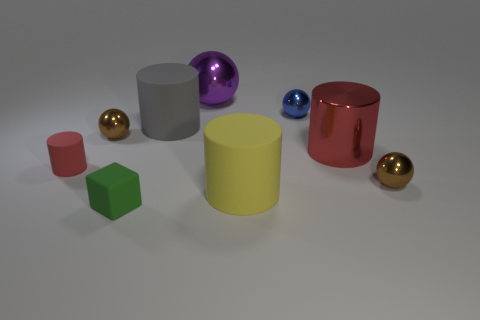The object that is the same color as the small rubber cylinder is what shape?
Keep it short and to the point. Cylinder. What number of large purple things are there?
Offer a very short reply. 1. What number of cylinders are either big yellow objects or gray objects?
Make the answer very short. 2. What number of tiny spheres are right of the matte cylinder that is on the right side of the big matte cylinder behind the big yellow matte cylinder?
Make the answer very short. 2. The shiny sphere that is the same size as the gray object is what color?
Your answer should be very brief. Purple. What number of other objects are there of the same color as the big shiny sphere?
Offer a terse response. 0. Is the number of small rubber objects that are in front of the red rubber cylinder greater than the number of big red rubber blocks?
Keep it short and to the point. Yes. Is the material of the big gray thing the same as the tiny red cylinder?
Provide a short and direct response. Yes. What number of things are either brown metallic things behind the small matte cylinder or cylinders?
Provide a short and direct response. 5. How many other objects are the same size as the yellow cylinder?
Your answer should be compact. 3. 